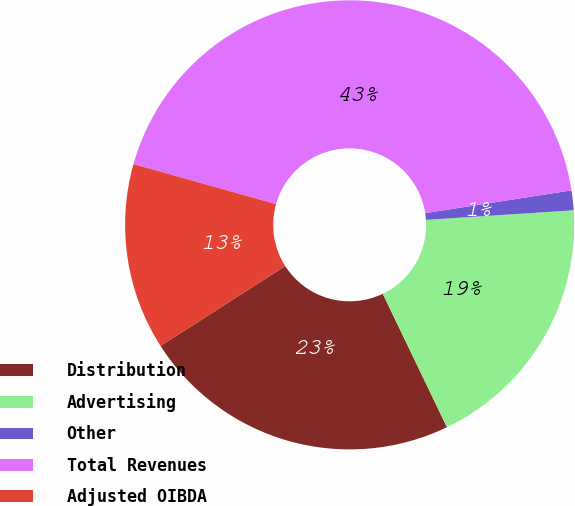Convert chart to OTSL. <chart><loc_0><loc_0><loc_500><loc_500><pie_chart><fcel>Distribution<fcel>Advertising<fcel>Other<fcel>Total Revenues<fcel>Adjusted OIBDA<nl><fcel>23.07%<fcel>18.9%<fcel>1.42%<fcel>43.18%<fcel>13.42%<nl></chart> 